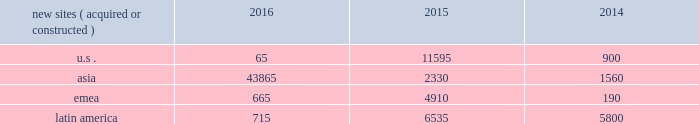In emerging markets , such as ghana , india , nigeria and uganda , wireless networks tend to be significantly less advanced than those in the united states , and initial voice networks continue to be deployed in underdeveloped areas .
A majority of consumers in these markets still utilize basic wireless services , predominantly on feature phones , while advanced device penetration remains low .
In more developed urban locations within these markets , early-stage data network deployments are underway .
Carriers are focused on completing voice network build-outs while also investing in initial data networks as wireless data usage and smartphone penetration within their customer bases begin to accelerate .
In markets with rapidly evolving network technology , such as south africa and most of the countries in latin america where we do business , initial voice networks , for the most part , have already been built out , and carriers are focused on 3g and 4g network build outs .
Consumers in these regions are increasingly adopting smartphones and other advanced devices , and , as a result , the usage of bandwidth-intensive mobile applications is growing materially .
Recent spectrum auctions in these rapidly evolving markets have allowed incumbent carriers to accelerate their data network deployments and have also enabled new entrants to begin initial investments in data networks .
Smartphone penetration and wireless data usage in these markets are growing rapidly , which typically requires that carriers continue to invest in their networks in order to maintain and augment their quality of service .
Finally , in markets with more mature network technology , such as germany and france , carriers are focused on deploying 4g data networks to account for rapidly increasing wireless data usage among their customer base .
With higher smartphone and advanced device penetration and significantly higher per capita data usage , carrier investment in networks is focused on 4g coverage and capacity .
We believe that the network technology migration we have seen in the united states , which has led to significantly denser networks and meaningful new business commencements for us over a number of years , will ultimately be replicated in our less advanced international markets .
As a result , we expect to be able to leverage our extensive international portfolio of approximately 104470 communications sites and the relationships we have built with our carrier customers to drive sustainable , long-term growth .
We have master lease agreements with certain of our tenants that provide for consistent , long-term revenue and reduce the likelihood of churn .
Our master lease agreements build and augment strong strategic partnerships with our tenants and have significantly reduced colocation cycle times , thereby providing our tenants with the ability to rapidly and efficiently deploy equipment on our sites .
Property operations new site revenue growth .
During the year ended december 31 , 2016 , we grew our portfolio of communications real estate through the acquisition and construction of approximately 45310 sites .
In a majority of our asia , emea and latin america markets , the revenue generated from newly acquired or constructed sites resulted in increases in both tenant and pass-through revenues ( such as ground rent or power and fuel costs ) and expenses .
We continue to evaluate opportunities to acquire communications real estate portfolios , both domestically and internationally , to determine whether they meet our risk-adjusted hurdle rates and whether we believe we can effectively integrate them into our existing portfolio. .
Property operations expenses .
Direct operating expenses incurred by our property segments include direct site level expenses and consist primarily of ground rent and power and fuel costs , some or all of which may be passed through to our tenants , as well as property taxes , repairs and maintenance .
These segment direct operating expenses exclude all segment and corporate selling , general , administrative and development expenses , which are aggregated into one line item entitled selling , general , administrative and development expense in our consolidated statements of operations .
In general , our property segments 2019 selling , general , administrative and development expenses do not significantly increase as a result of adding incremental tenants to our sites and typically increase only modestly year-over-year .
As a result , leasing additional space to new tenants on our sites provides significant incremental cash flow .
We may , however , incur additional segment selling , general , administrative and development expenses as we increase our presence in our existing markets or expand into new markets .
Our profit margin growth is therefore positively impacted by the addition of new tenants to our sites but can be temporarily diluted by our development activities. .
What is the total number of new sites acquired and constructed during 2015? 
Computations: (((11595 + 2330) + 4910) + 6535)
Answer: 25370.0. 